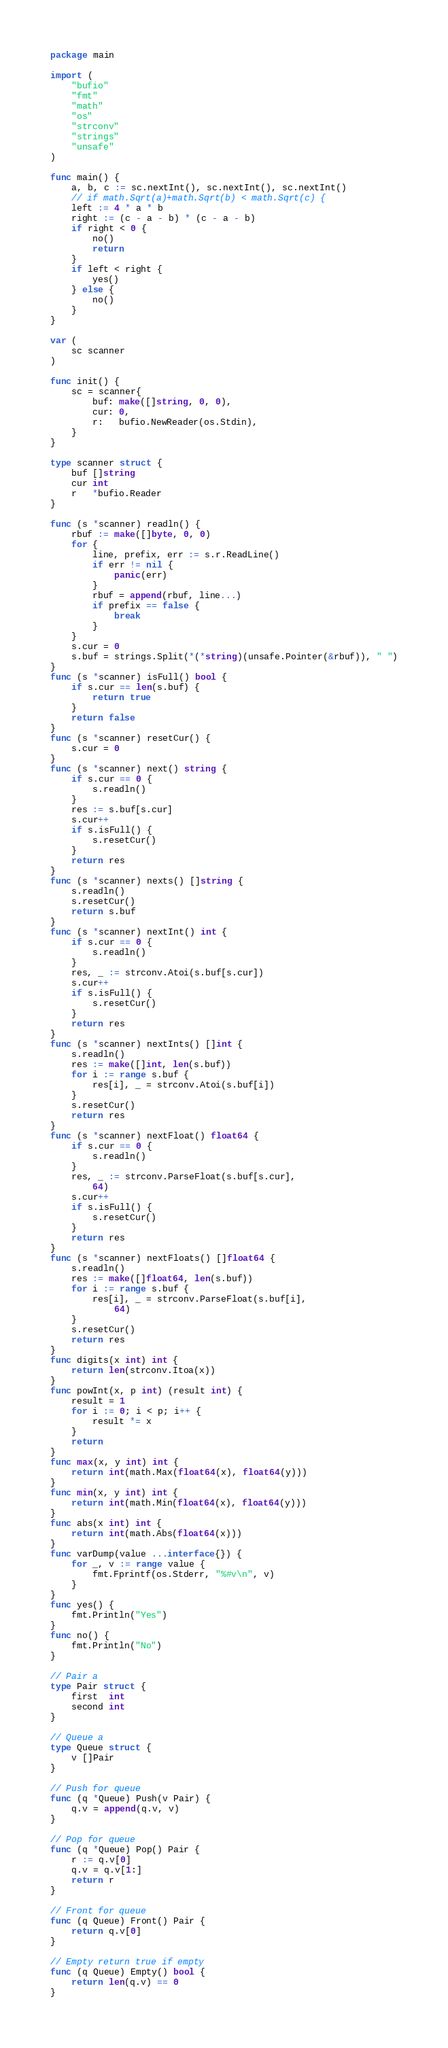<code> <loc_0><loc_0><loc_500><loc_500><_Go_>package main

import (
	"bufio"
	"fmt"
	"math"
	"os"
	"strconv"
	"strings"
	"unsafe"
)

func main() {
	a, b, c := sc.nextInt(), sc.nextInt(), sc.nextInt()
	// if math.Sqrt(a)+math.Sqrt(b) < math.Sqrt(c) {
	left := 4 * a * b
	right := (c - a - b) * (c - a - b)
	if right < 0 {
		no()
		return
	}
	if left < right {
		yes()
	} else {
		no()
	}
}

var (
	sc scanner
)

func init() {
	sc = scanner{
		buf: make([]string, 0, 0),
		cur: 0,
		r:   bufio.NewReader(os.Stdin),
	}
}

type scanner struct {
	buf []string
	cur int
	r   *bufio.Reader
}

func (s *scanner) readln() {
	rbuf := make([]byte, 0, 0)
	for {
		line, prefix, err := s.r.ReadLine()
		if err != nil {
			panic(err)
		}
		rbuf = append(rbuf, line...)
		if prefix == false {
			break
		}
	}
	s.cur = 0
	s.buf = strings.Split(*(*string)(unsafe.Pointer(&rbuf)), " ")
}
func (s *scanner) isFull() bool {
	if s.cur == len(s.buf) {
		return true
	}
	return false
}
func (s *scanner) resetCur() {
	s.cur = 0
}
func (s *scanner) next() string {
	if s.cur == 0 {
		s.readln()
	}
	res := s.buf[s.cur]
	s.cur++
	if s.isFull() {
		s.resetCur()
	}
	return res
}
func (s *scanner) nexts() []string {
	s.readln()
	s.resetCur()
	return s.buf
}
func (s *scanner) nextInt() int {
	if s.cur == 0 {
		s.readln()
	}
	res, _ := strconv.Atoi(s.buf[s.cur])
	s.cur++
	if s.isFull() {
		s.resetCur()
	}
	return res
}
func (s *scanner) nextInts() []int {
	s.readln()
	res := make([]int, len(s.buf))
	for i := range s.buf {
		res[i], _ = strconv.Atoi(s.buf[i])
	}
	s.resetCur()
	return res
}
func (s *scanner) nextFloat() float64 {
	if s.cur == 0 {
		s.readln()
	}
	res, _ := strconv.ParseFloat(s.buf[s.cur],
		64)
	s.cur++
	if s.isFull() {
		s.resetCur()
	}
	return res
}
func (s *scanner) nextFloats() []float64 {
	s.readln()
	res := make([]float64, len(s.buf))
	for i := range s.buf {
		res[i], _ = strconv.ParseFloat(s.buf[i],
			64)
	}
	s.resetCur()
	return res
}
func digits(x int) int {
	return len(strconv.Itoa(x))
}
func powInt(x, p int) (result int) {
	result = 1
	for i := 0; i < p; i++ {
		result *= x
	}
	return
}
func max(x, y int) int {
	return int(math.Max(float64(x), float64(y)))
}
func min(x, y int) int {
	return int(math.Min(float64(x), float64(y)))
}
func abs(x int) int {
	return int(math.Abs(float64(x)))
}
func varDump(value ...interface{}) {
	for _, v := range value {
		fmt.Fprintf(os.Stderr, "%#v\n", v)
	}
}
func yes() {
	fmt.Println("Yes")
}
func no() {
	fmt.Println("No")
}

// Pair a
type Pair struct {
	first  int
	second int
}

// Queue a
type Queue struct {
	v []Pair
}

// Push for queue
func (q *Queue) Push(v Pair) {
	q.v = append(q.v, v)
}

// Pop for queue
func (q *Queue) Pop() Pair {
	r := q.v[0]
	q.v = q.v[1:]
	return r
}

// Front for queue
func (q Queue) Front() Pair {
	return q.v[0]
}

// Empty return true if empty
func (q Queue) Empty() bool {
	return len(q.v) == 0
}
</code> 